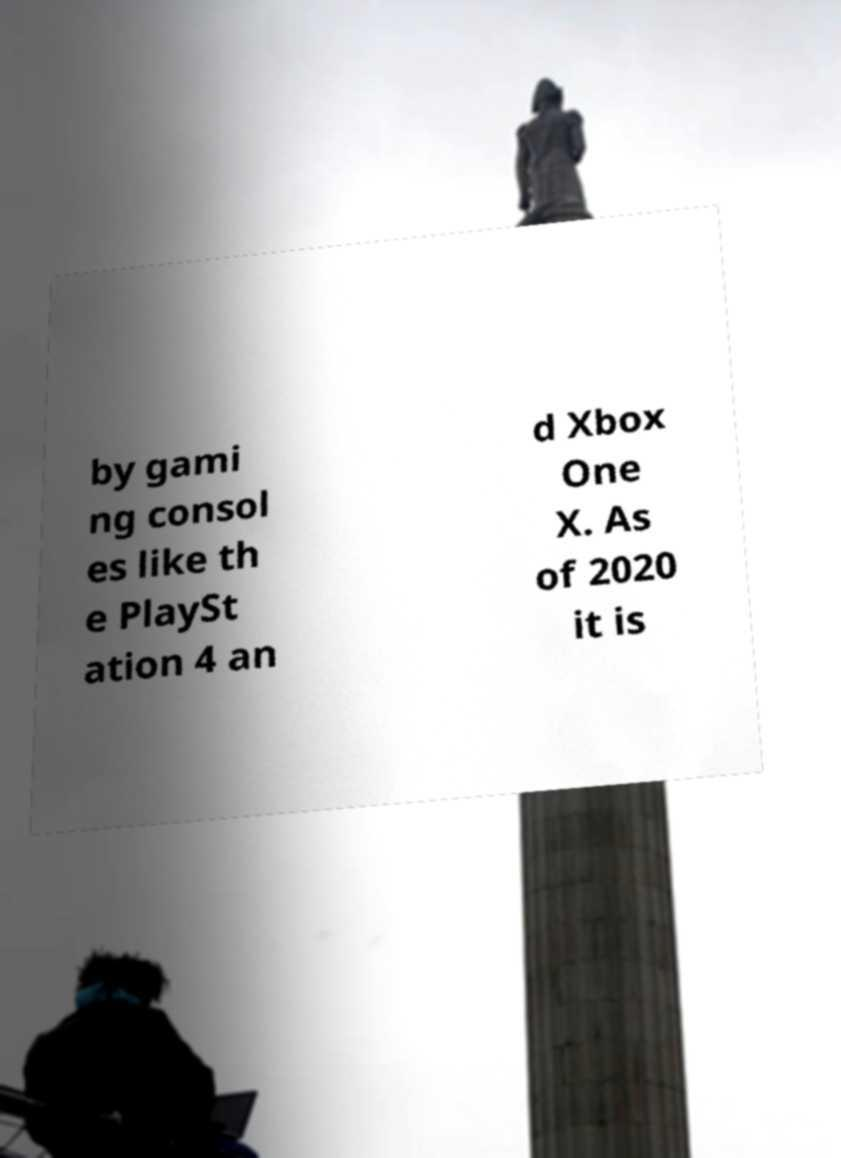I need the written content from this picture converted into text. Can you do that? by gami ng consol es like th e PlaySt ation 4 an d Xbox One X. As of 2020 it is 